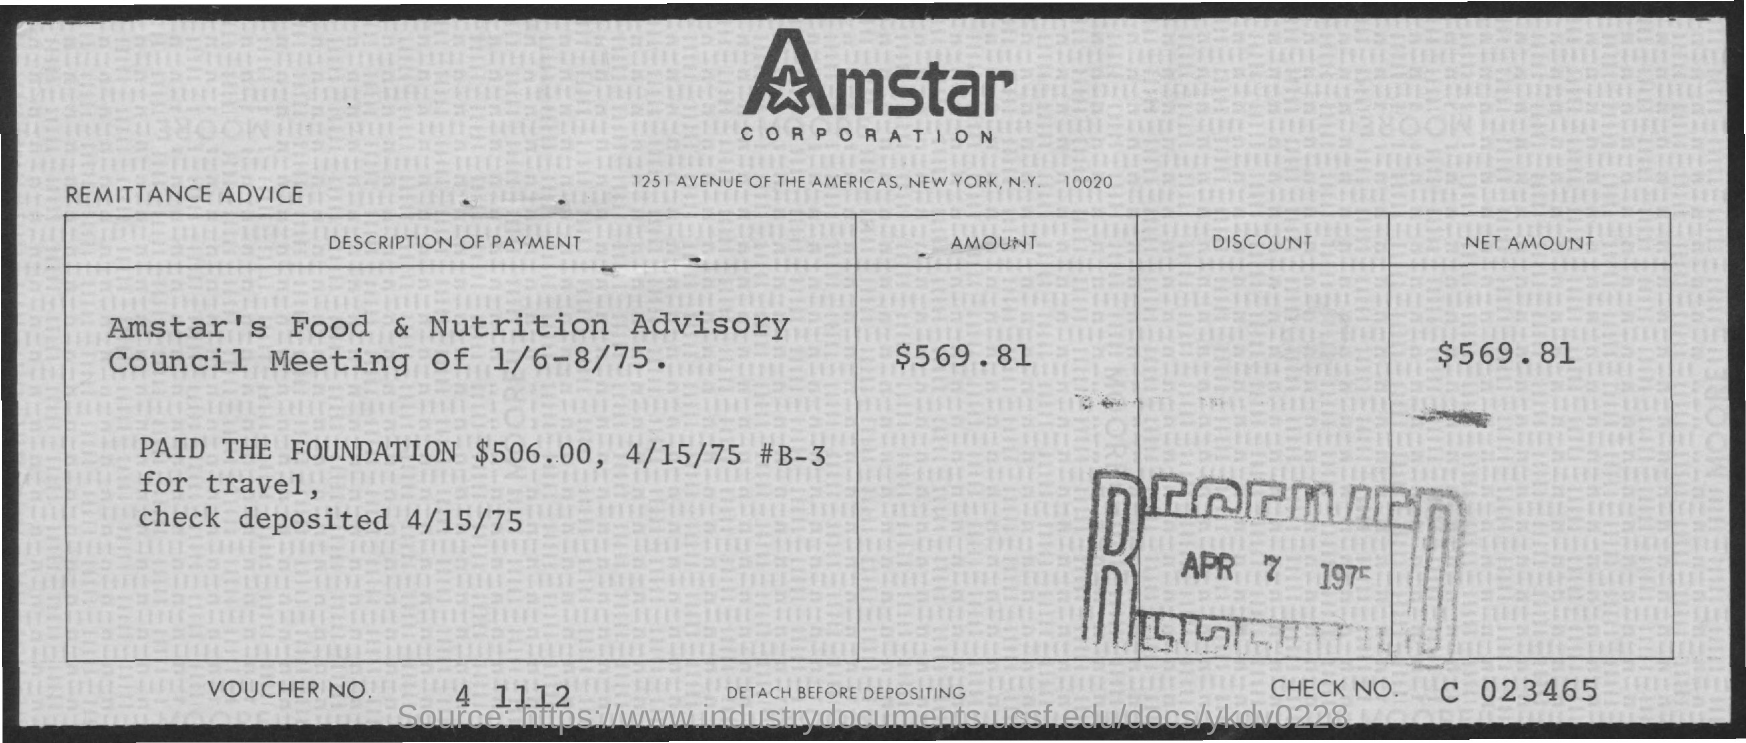What is the Voucher No. given in the remittance advice slip?
Provide a succinct answer. 4 1112. Which company is mentioned in the header of the document?
Provide a short and direct response. Amstar Corporation. What is the net amount mentioned in the remittance advice slip?
Make the answer very short. $569.81. What is the check no. given in the remittance advice slip?
Your response must be concise. C 023465. What is the date of check deposited mentioned in the remittance advice slip?
Make the answer very short. 4/15/75. 